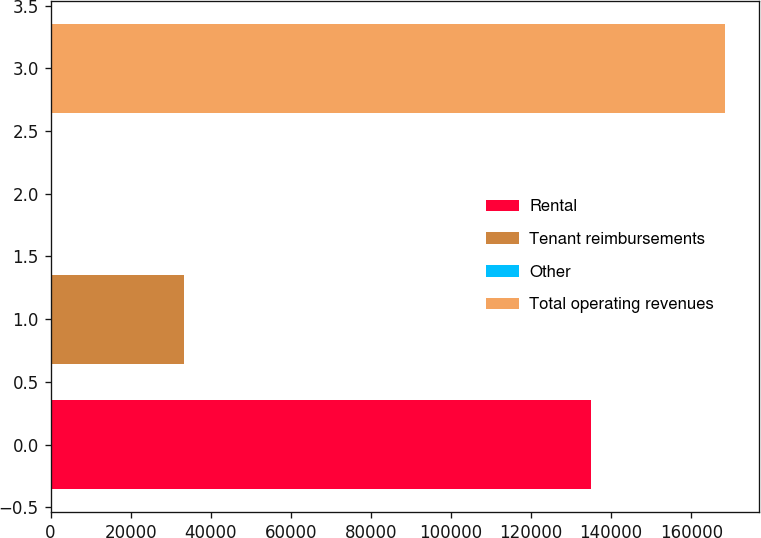Convert chart. <chart><loc_0><loc_0><loc_500><loc_500><bar_chart><fcel>Rental<fcel>Tenant reimbursements<fcel>Other<fcel>Total operating revenues<nl><fcel>135031<fcel>33317<fcel>197<fcel>168545<nl></chart> 